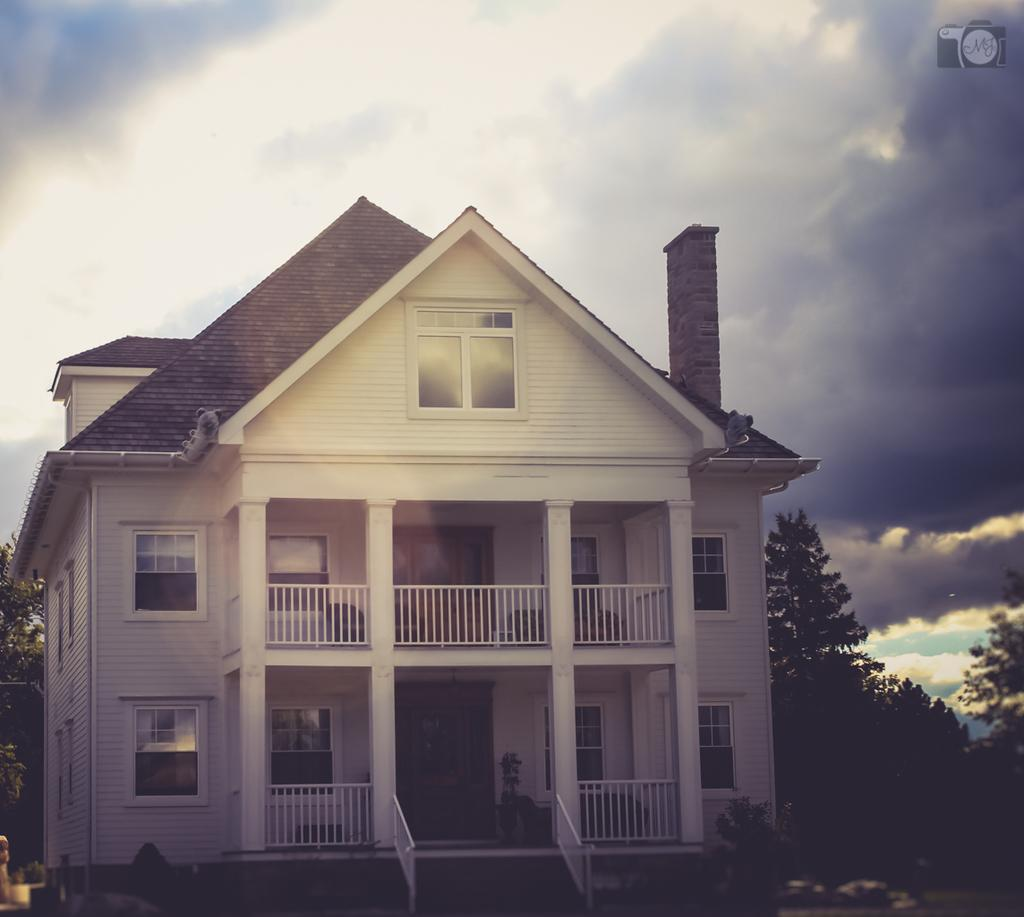What type of structure is visible in the image? There is a building in the image. What other natural elements can be seen in the image? There are trees and plants visible in the image. How would you describe the weather based on the image? The sky is cloudy in the image, suggesting a potentially overcast or cloudy day. Where is the logo located in the image? The logo is at the top right corner of the image. What type of wood is used to transport butter in the image? There is no wood, transport, or butter present in the image. 